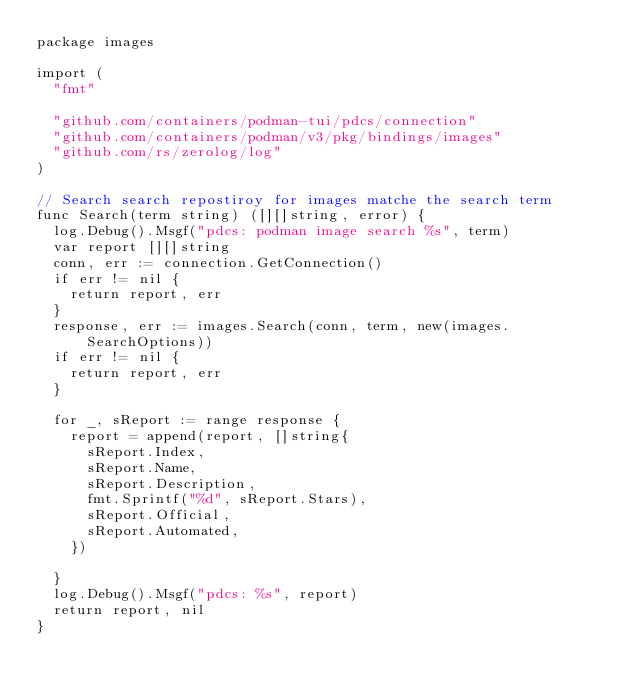Convert code to text. <code><loc_0><loc_0><loc_500><loc_500><_Go_>package images

import (
	"fmt"

	"github.com/containers/podman-tui/pdcs/connection"
	"github.com/containers/podman/v3/pkg/bindings/images"
	"github.com/rs/zerolog/log"
)

// Search search repostiroy for images matche the search term
func Search(term string) ([][]string, error) {
	log.Debug().Msgf("pdcs: podman image search %s", term)
	var report [][]string
	conn, err := connection.GetConnection()
	if err != nil {
		return report, err
	}
	response, err := images.Search(conn, term, new(images.SearchOptions))
	if err != nil {
		return report, err
	}

	for _, sReport := range response {
		report = append(report, []string{
			sReport.Index,
			sReport.Name,
			sReport.Description,
			fmt.Sprintf("%d", sReport.Stars),
			sReport.Official,
			sReport.Automated,
		})

	}
	log.Debug().Msgf("pdcs: %s", report)
	return report, nil
}
</code> 